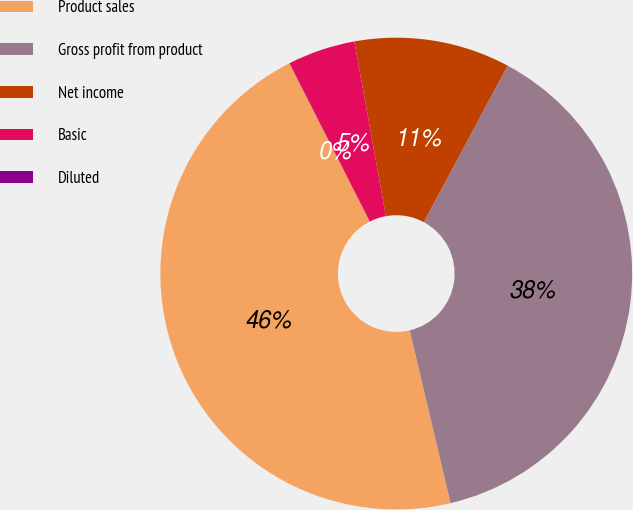Convert chart to OTSL. <chart><loc_0><loc_0><loc_500><loc_500><pie_chart><fcel>Product sales<fcel>Gross profit from product<fcel>Net income<fcel>Basic<fcel>Diluted<nl><fcel>46.22%<fcel>38.48%<fcel>10.67%<fcel>4.63%<fcel>0.01%<nl></chart> 